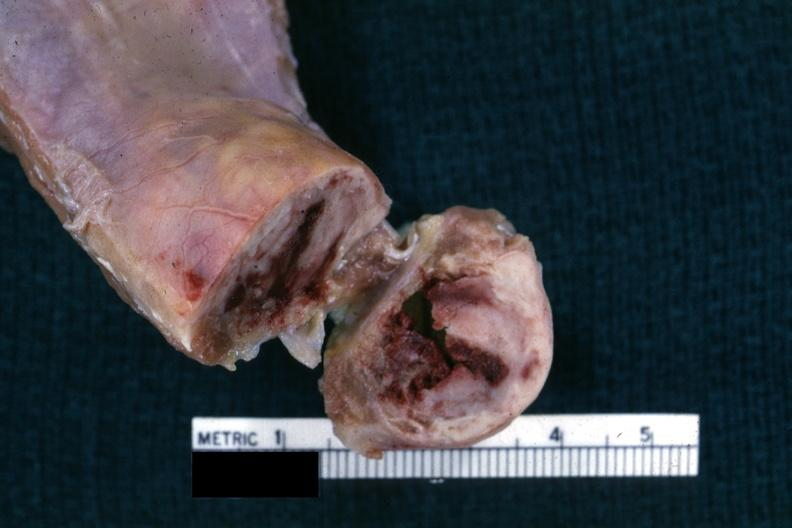s crookes cells present?
Answer the question using a single word or phrase. No 